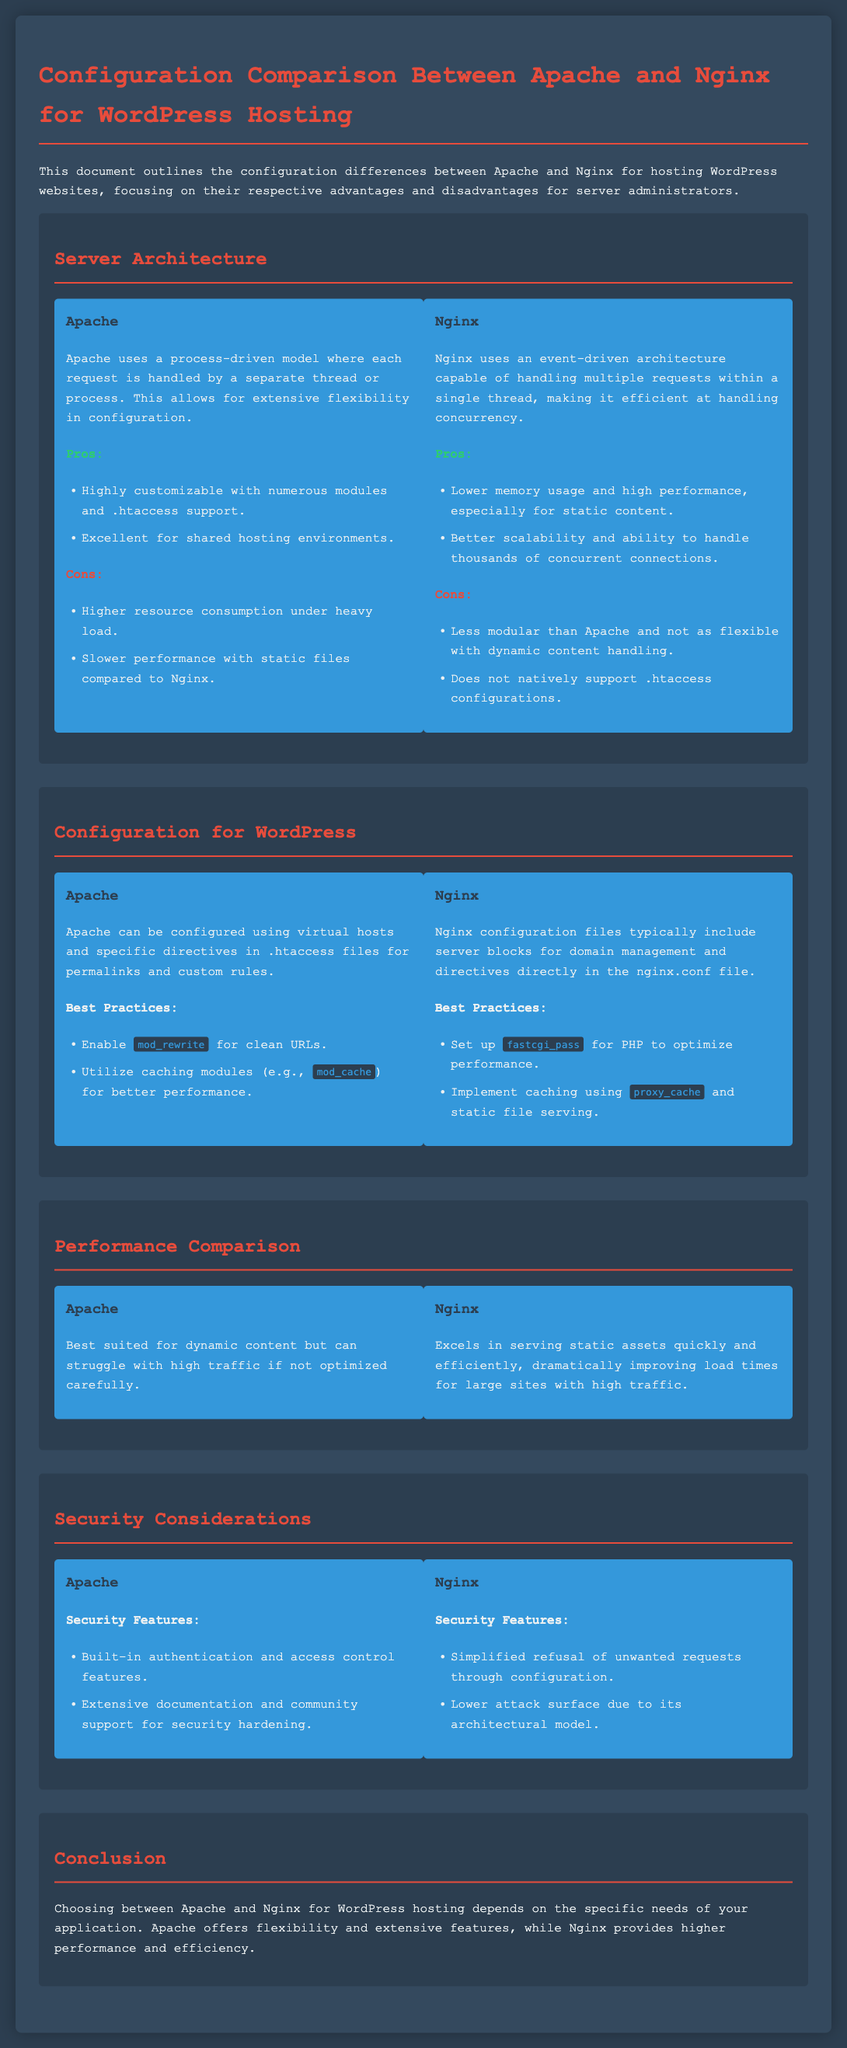What is the server architecture model used by Apache? Apache uses a process-driven model where each request is handled by a separate thread or process.
Answer: Process-driven model What is one main advantage of using Nginx? Nginx has the benefit of lower memory usage and high performance, especially for static content.
Answer: Lower memory usage What configuration directive should be enabled in Apache for clean URLs? The directive that should be enabled is mod_rewrite.
Answer: mod_rewrite Which server is better at handling thousands of concurrent connections? Nginx is better at handling thousands of concurrent connections as it uses an event-driven architecture.
Answer: Nginx What security feature does Apache offer? Apache offers built-in authentication and access control features.
Answer: Built-in authentication What type of content does Nginx excel in serving? Nginx excels in serving static assets quickly and efficiently.
Answer: Static assets How does Apache perform under high traffic if not optimized? Apache can struggle with high traffic if not optimized carefully.
Answer: Struggle Which configuration approach does Nginx typically use for domain management? Nginx configuration files typically include server blocks for domain management.
Answer: Server blocks 